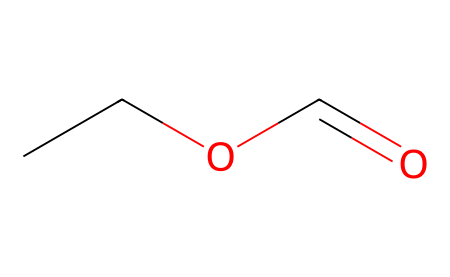How many carbon atoms are in ethyl formate? The SMILES representation indicates there are two carbon atoms in the ethyl group (CC) and one carbon atom in the carbonyl group (C=O), totaling three carbon atoms.
Answer: three What is the functional group present in ethyl formate? The SMILES structure shows a carbonyl group (C=O) adjacent to an alkoxy group (OC), indicating the presence of an ester functional group.
Answer: ester How many hydrogen atoms are present in ethyl formate? Analyzing the SMILES representation, the ethyl group contributes five hydrogen atoms, and the carbonyl does not add any; thus, there are five hydrogen atoms in total.
Answer: five What type of intermolecular forces would you expect in ethyl formate? The presence of the polar carbonyl group suggests dipole-dipole interactions, while the overall molecular structure allows for potential van der Waals forces as well.
Answer: dipole-dipole interactions Why is ethyl formate used as a fumigant for animal housing? The ester structure of ethyl formate allows for volatility and a pleasant smell, making it effective in repelling pests while being less harmful to animals when used appropriately.
Answer: volatility and pleasant smell How many oxygen atoms are in ethyl formate? The SMILES shows one oxygen in the carbonyl part (C=O) and one in the alkoxy part (OC), totaling two oxygen atoms in the molecule.
Answer: two What property makes ethyl formate suitable for use in feed storage? The ester is less soluble in water, which helps in retaining its effectiveness as a fumigant by not being easily washed away.
Answer: less soluble in water 